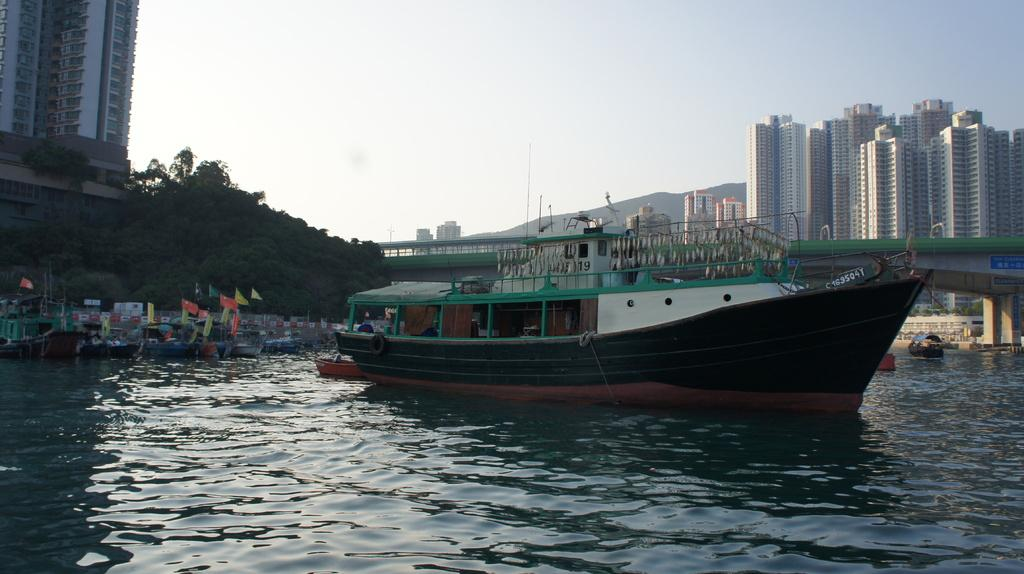<image>
Share a concise interpretation of the image provided. A boat with the number C163504Y on it 